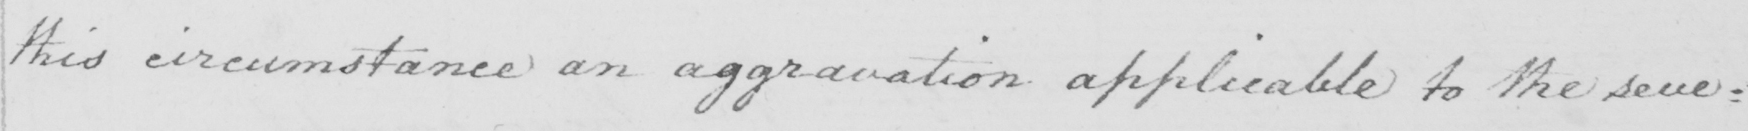Can you tell me what this handwritten text says? this circumstance an aggravation applicable to the seve= 